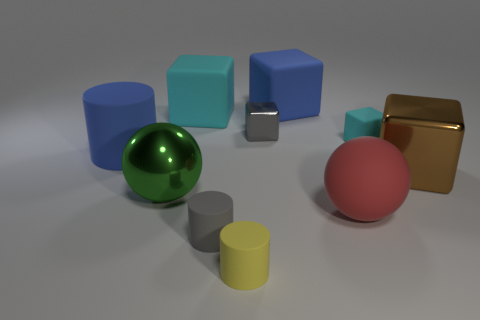Subtract 2 blocks. How many blocks are left? 3 Subtract all purple blocks. Subtract all brown balls. How many blocks are left? 5 Subtract all cylinders. How many objects are left? 7 Add 2 large green metal balls. How many large green metal balls are left? 3 Add 7 big red matte cylinders. How many big red matte cylinders exist? 7 Subtract 0 red cylinders. How many objects are left? 10 Subtract all red matte blocks. Subtract all gray metal things. How many objects are left? 9 